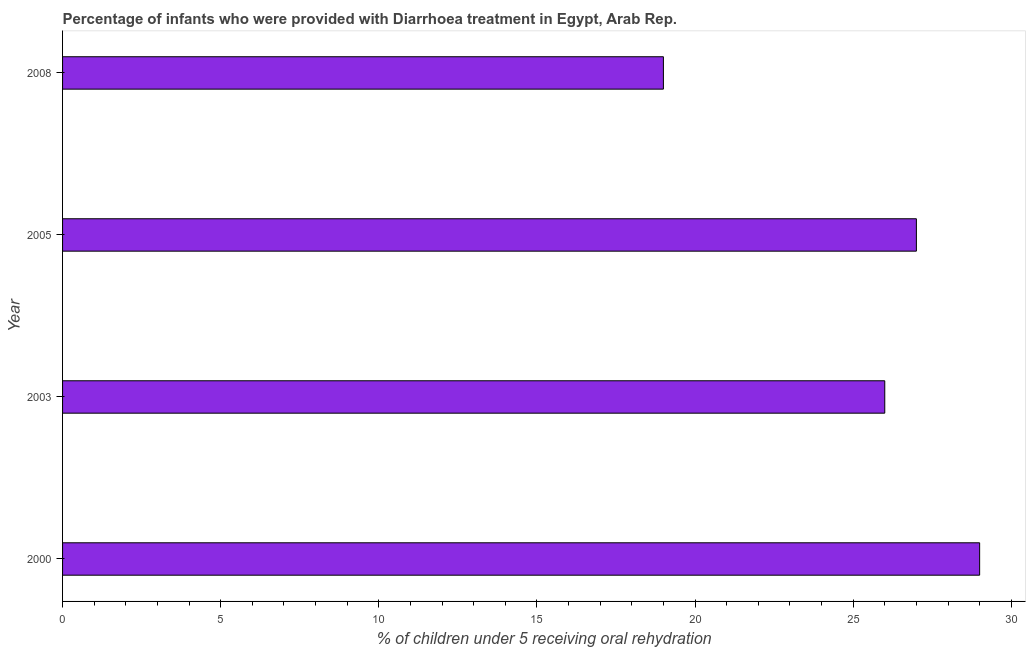Does the graph contain any zero values?
Your answer should be very brief. No. Does the graph contain grids?
Your response must be concise. No. What is the title of the graph?
Your answer should be compact. Percentage of infants who were provided with Diarrhoea treatment in Egypt, Arab Rep. What is the label or title of the X-axis?
Make the answer very short. % of children under 5 receiving oral rehydration. In which year was the percentage of children who were provided with treatment diarrhoea maximum?
Give a very brief answer. 2000. What is the sum of the percentage of children who were provided with treatment diarrhoea?
Provide a succinct answer. 101. What is the average percentage of children who were provided with treatment diarrhoea per year?
Offer a terse response. 25. What is the ratio of the percentage of children who were provided with treatment diarrhoea in 2003 to that in 2005?
Give a very brief answer. 0.96. Is the percentage of children who were provided with treatment diarrhoea in 2000 less than that in 2003?
Offer a very short reply. No. Is the difference between the percentage of children who were provided with treatment diarrhoea in 2005 and 2008 greater than the difference between any two years?
Keep it short and to the point. No. What is the difference between the highest and the second highest percentage of children who were provided with treatment diarrhoea?
Provide a succinct answer. 2. Is the sum of the percentage of children who were provided with treatment diarrhoea in 2003 and 2005 greater than the maximum percentage of children who were provided with treatment diarrhoea across all years?
Give a very brief answer. Yes. In how many years, is the percentage of children who were provided with treatment diarrhoea greater than the average percentage of children who were provided with treatment diarrhoea taken over all years?
Keep it short and to the point. 3. How many bars are there?
Your answer should be very brief. 4. Are all the bars in the graph horizontal?
Give a very brief answer. Yes. Are the values on the major ticks of X-axis written in scientific E-notation?
Keep it short and to the point. No. What is the % of children under 5 receiving oral rehydration of 2000?
Ensure brevity in your answer.  29. What is the % of children under 5 receiving oral rehydration of 2008?
Keep it short and to the point. 19. What is the difference between the % of children under 5 receiving oral rehydration in 2000 and 2003?
Your response must be concise. 3. What is the difference between the % of children under 5 receiving oral rehydration in 2000 and 2005?
Ensure brevity in your answer.  2. What is the difference between the % of children under 5 receiving oral rehydration in 2000 and 2008?
Give a very brief answer. 10. What is the difference between the % of children under 5 receiving oral rehydration in 2003 and 2008?
Make the answer very short. 7. What is the ratio of the % of children under 5 receiving oral rehydration in 2000 to that in 2003?
Your response must be concise. 1.11. What is the ratio of the % of children under 5 receiving oral rehydration in 2000 to that in 2005?
Provide a succinct answer. 1.07. What is the ratio of the % of children under 5 receiving oral rehydration in 2000 to that in 2008?
Your answer should be compact. 1.53. What is the ratio of the % of children under 5 receiving oral rehydration in 2003 to that in 2008?
Your response must be concise. 1.37. What is the ratio of the % of children under 5 receiving oral rehydration in 2005 to that in 2008?
Offer a very short reply. 1.42. 